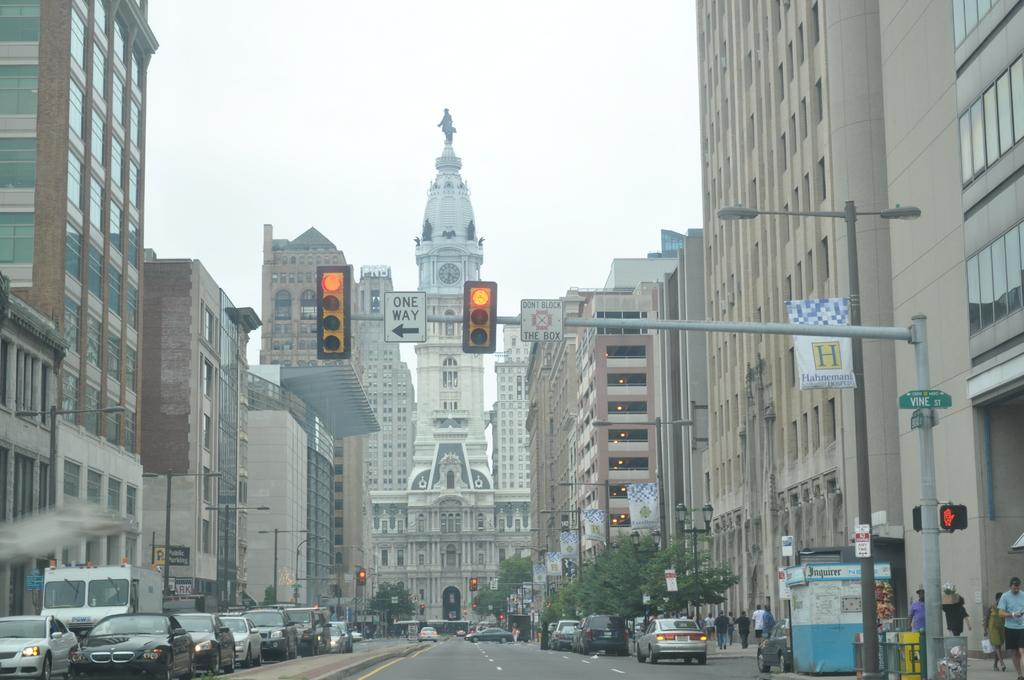Provide a one-sentence caption for the provided image. Two traffic lights on yellow with a one way sign between them. 